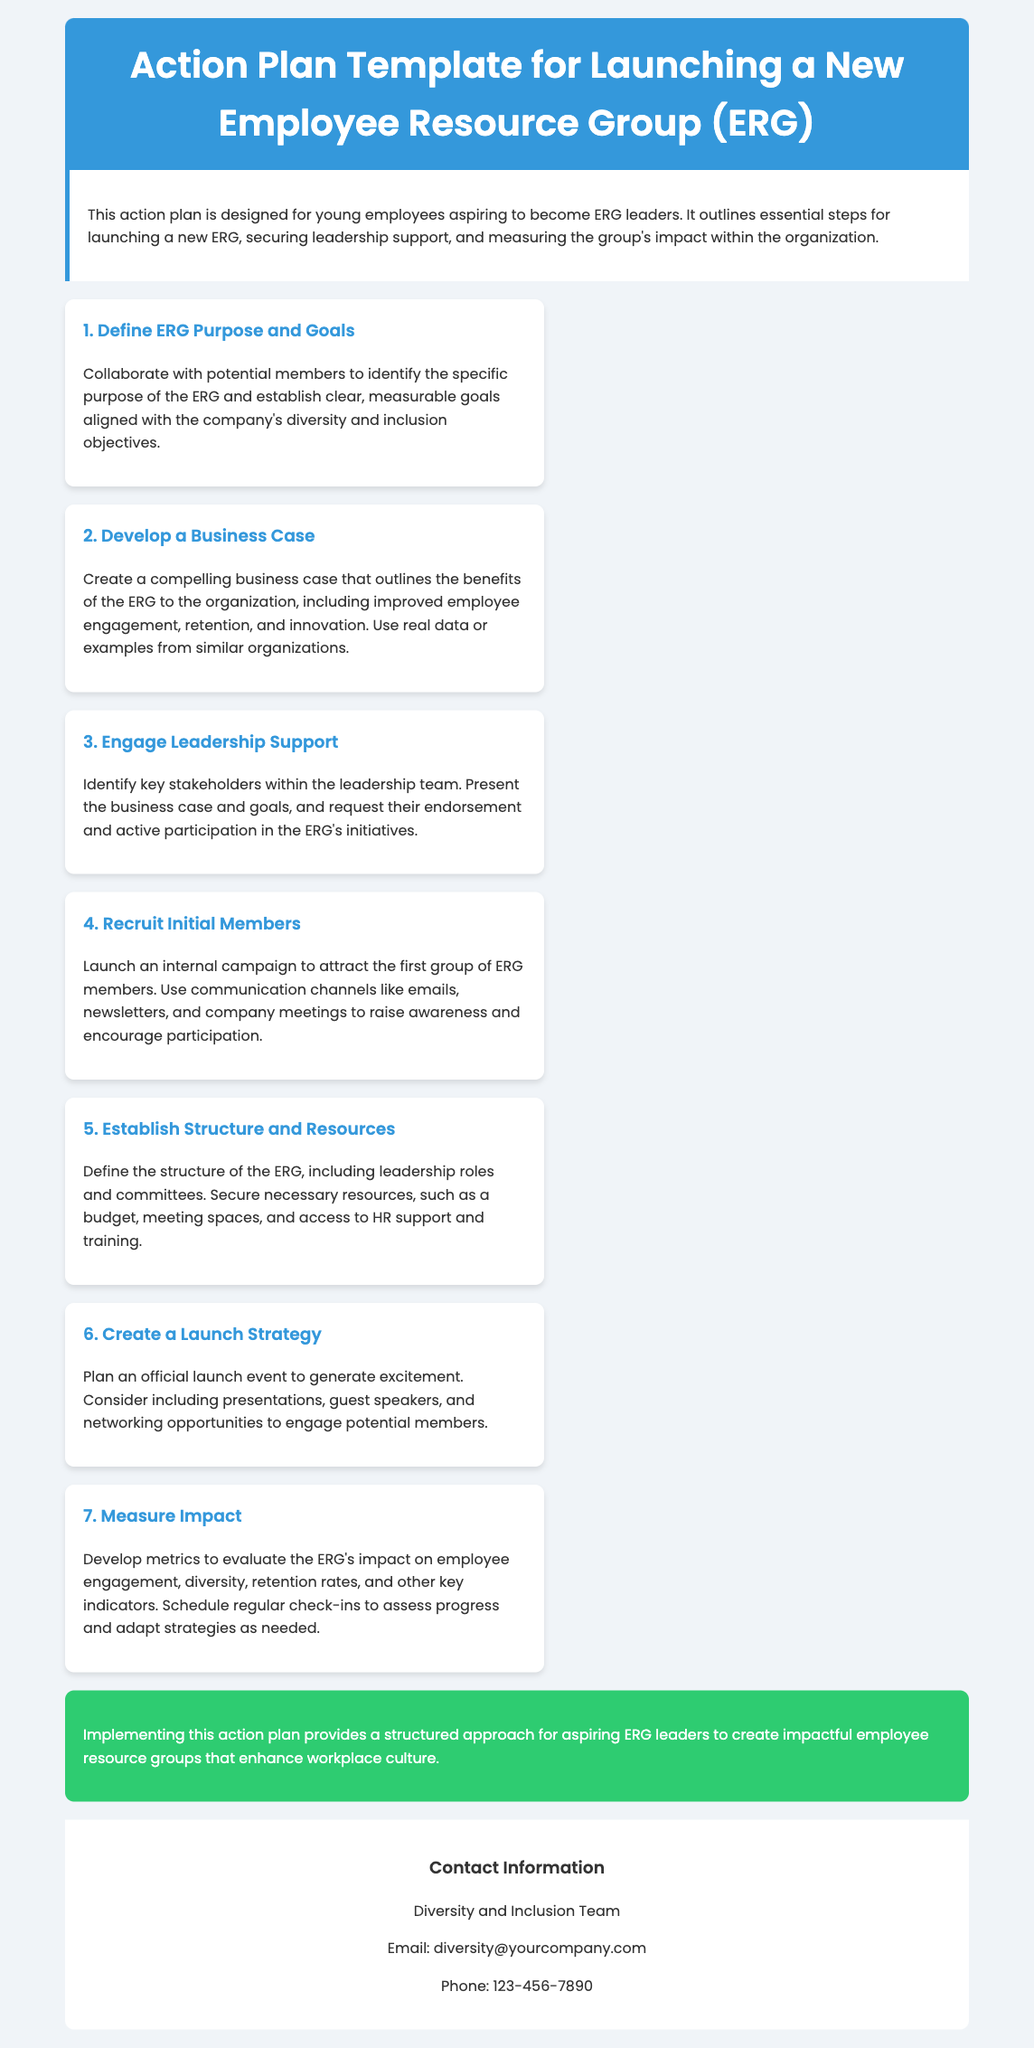What is the title of the document? The title of the document is presented in the header section of the HTML, specifically stating the purpose of the action plan.
Answer: Action Plan Template for Launching a New Employee Resource Group (ERG) How many steps are outlined in the action plan? The document lists a total of seven distinct steps for launching an ERG, each described in individual sections.
Answer: 7 What is the primary audience for this action plan? The introductory section specifies that the document is designed especially for young employees who aspire to take on leadership roles in ERGs.
Answer: Young employees What color is the header background? The HTML shows the header is styled with a background color, which aligns with the theme of the ERG action plan.
Answer: #3498db Which step involves recruiting ERG members? The fourth step is specifically focused on the action of attracting and enlisting initial members to the ERG group.
Answer: Recruit Initial Members What is the purpose of measuring impact according to the last step? The last step emphasizes evaluating the ERG's effectiveness in various organizational aspects using specific metrics.
Answer: Develop metrics Who should be contacted for more information? The contact section provides details about the Diversity and Inclusion Team, indicating who to reach out to for further inquiries.
Answer: Diversity and Inclusion Team 